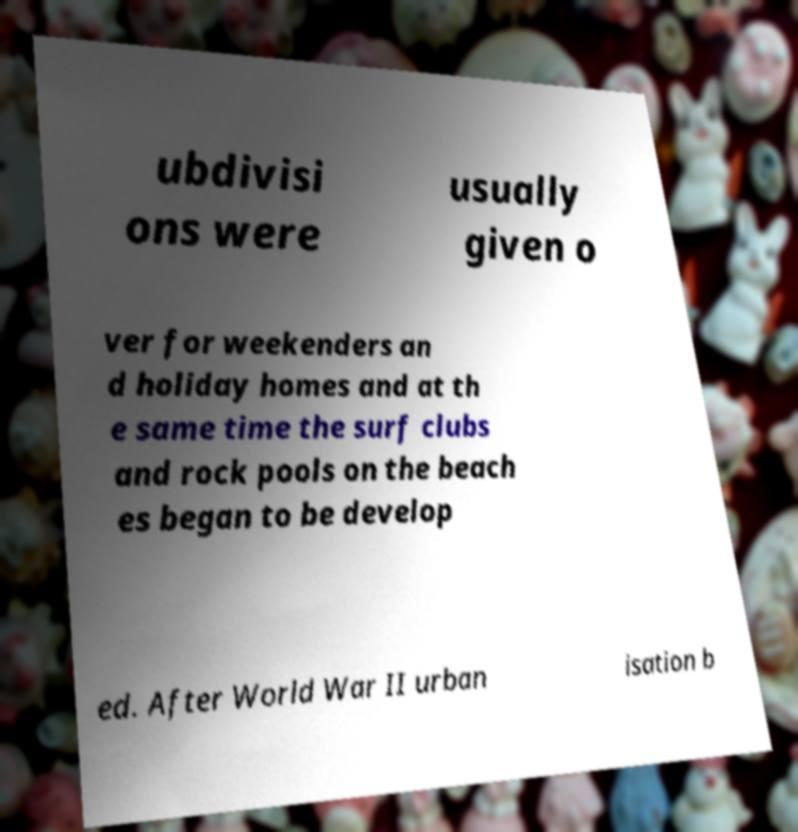Please read and relay the text visible in this image. What does it say? ubdivisi ons were usually given o ver for weekenders an d holiday homes and at th e same time the surf clubs and rock pools on the beach es began to be develop ed. After World War II urban isation b 